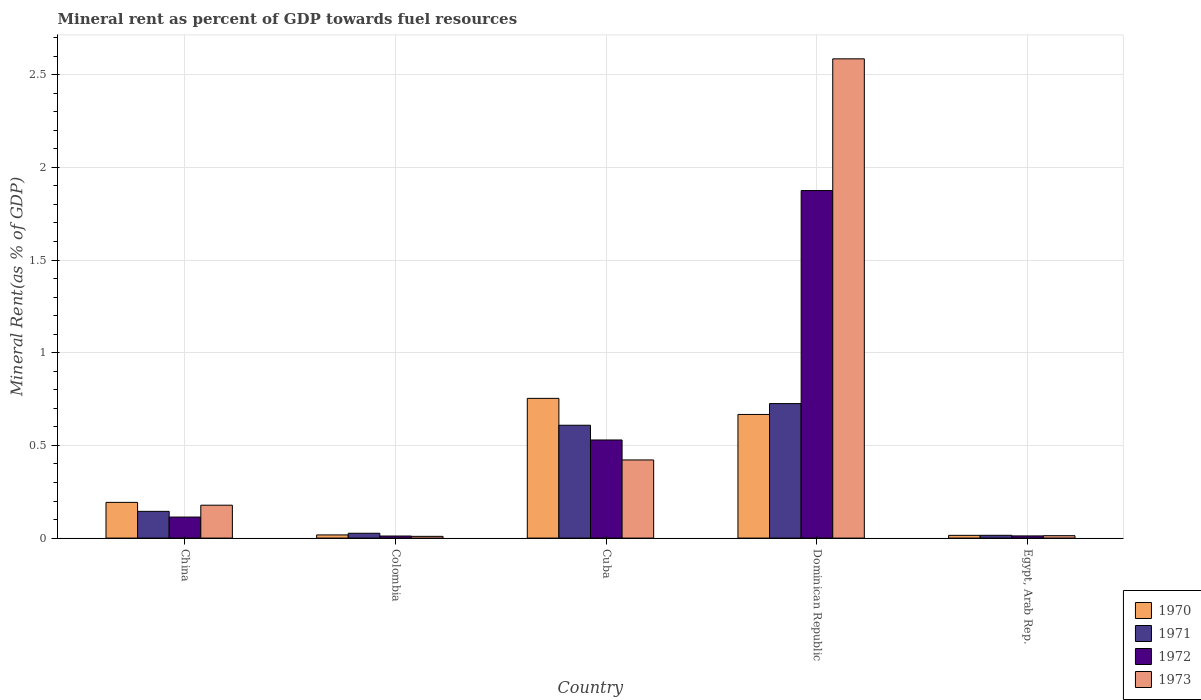How many groups of bars are there?
Ensure brevity in your answer.  5. Are the number of bars per tick equal to the number of legend labels?
Make the answer very short. Yes. Are the number of bars on each tick of the X-axis equal?
Offer a very short reply. Yes. How many bars are there on the 3rd tick from the left?
Make the answer very short. 4. What is the label of the 3rd group of bars from the left?
Your answer should be very brief. Cuba. What is the mineral rent in 1971 in Egypt, Arab Rep.?
Give a very brief answer. 0.02. Across all countries, what is the maximum mineral rent in 1970?
Provide a succinct answer. 0.75. Across all countries, what is the minimum mineral rent in 1970?
Provide a succinct answer. 0.01. In which country was the mineral rent in 1973 maximum?
Give a very brief answer. Dominican Republic. In which country was the mineral rent in 1970 minimum?
Make the answer very short. Egypt, Arab Rep. What is the total mineral rent in 1973 in the graph?
Offer a terse response. 3.21. What is the difference between the mineral rent in 1973 in Colombia and that in Cuba?
Your answer should be very brief. -0.41. What is the difference between the mineral rent in 1971 in China and the mineral rent in 1973 in Cuba?
Ensure brevity in your answer.  -0.28. What is the average mineral rent in 1970 per country?
Ensure brevity in your answer.  0.33. What is the difference between the mineral rent of/in 1970 and mineral rent of/in 1972 in Dominican Republic?
Make the answer very short. -1.21. What is the ratio of the mineral rent in 1970 in Colombia to that in Cuba?
Make the answer very short. 0.02. Is the mineral rent in 1971 in China less than that in Egypt, Arab Rep.?
Give a very brief answer. No. Is the difference between the mineral rent in 1970 in Colombia and Egypt, Arab Rep. greater than the difference between the mineral rent in 1972 in Colombia and Egypt, Arab Rep.?
Keep it short and to the point. Yes. What is the difference between the highest and the second highest mineral rent in 1970?
Your answer should be compact. 0.09. What is the difference between the highest and the lowest mineral rent in 1973?
Your answer should be very brief. 2.58. Is it the case that in every country, the sum of the mineral rent in 1972 and mineral rent in 1973 is greater than the sum of mineral rent in 1970 and mineral rent in 1971?
Keep it short and to the point. No. What does the 1st bar from the left in Dominican Republic represents?
Your answer should be very brief. 1970. Is it the case that in every country, the sum of the mineral rent in 1973 and mineral rent in 1970 is greater than the mineral rent in 1971?
Offer a very short reply. Yes. How many bars are there?
Keep it short and to the point. 20. How many countries are there in the graph?
Make the answer very short. 5. Are the values on the major ticks of Y-axis written in scientific E-notation?
Keep it short and to the point. No. What is the title of the graph?
Your answer should be very brief. Mineral rent as percent of GDP towards fuel resources. Does "1983" appear as one of the legend labels in the graph?
Provide a succinct answer. No. What is the label or title of the X-axis?
Give a very brief answer. Country. What is the label or title of the Y-axis?
Offer a terse response. Mineral Rent(as % of GDP). What is the Mineral Rent(as % of GDP) of 1970 in China?
Provide a succinct answer. 0.19. What is the Mineral Rent(as % of GDP) in 1971 in China?
Keep it short and to the point. 0.14. What is the Mineral Rent(as % of GDP) in 1972 in China?
Your answer should be compact. 0.11. What is the Mineral Rent(as % of GDP) of 1973 in China?
Your answer should be very brief. 0.18. What is the Mineral Rent(as % of GDP) in 1970 in Colombia?
Your answer should be compact. 0.02. What is the Mineral Rent(as % of GDP) in 1971 in Colombia?
Your answer should be compact. 0.03. What is the Mineral Rent(as % of GDP) of 1972 in Colombia?
Your response must be concise. 0.01. What is the Mineral Rent(as % of GDP) of 1973 in Colombia?
Offer a terse response. 0.01. What is the Mineral Rent(as % of GDP) of 1970 in Cuba?
Make the answer very short. 0.75. What is the Mineral Rent(as % of GDP) of 1971 in Cuba?
Your response must be concise. 0.61. What is the Mineral Rent(as % of GDP) in 1972 in Cuba?
Provide a short and direct response. 0.53. What is the Mineral Rent(as % of GDP) of 1973 in Cuba?
Give a very brief answer. 0.42. What is the Mineral Rent(as % of GDP) of 1970 in Dominican Republic?
Give a very brief answer. 0.67. What is the Mineral Rent(as % of GDP) in 1971 in Dominican Republic?
Your answer should be compact. 0.73. What is the Mineral Rent(as % of GDP) in 1972 in Dominican Republic?
Your response must be concise. 1.87. What is the Mineral Rent(as % of GDP) of 1973 in Dominican Republic?
Your response must be concise. 2.59. What is the Mineral Rent(as % of GDP) in 1970 in Egypt, Arab Rep.?
Your answer should be compact. 0.01. What is the Mineral Rent(as % of GDP) in 1971 in Egypt, Arab Rep.?
Make the answer very short. 0.02. What is the Mineral Rent(as % of GDP) of 1972 in Egypt, Arab Rep.?
Make the answer very short. 0.01. What is the Mineral Rent(as % of GDP) of 1973 in Egypt, Arab Rep.?
Offer a very short reply. 0.01. Across all countries, what is the maximum Mineral Rent(as % of GDP) of 1970?
Ensure brevity in your answer.  0.75. Across all countries, what is the maximum Mineral Rent(as % of GDP) in 1971?
Your response must be concise. 0.73. Across all countries, what is the maximum Mineral Rent(as % of GDP) of 1972?
Your response must be concise. 1.87. Across all countries, what is the maximum Mineral Rent(as % of GDP) of 1973?
Ensure brevity in your answer.  2.59. Across all countries, what is the minimum Mineral Rent(as % of GDP) of 1970?
Offer a very short reply. 0.01. Across all countries, what is the minimum Mineral Rent(as % of GDP) of 1971?
Your answer should be compact. 0.02. Across all countries, what is the minimum Mineral Rent(as % of GDP) of 1972?
Provide a short and direct response. 0.01. Across all countries, what is the minimum Mineral Rent(as % of GDP) of 1973?
Keep it short and to the point. 0.01. What is the total Mineral Rent(as % of GDP) of 1970 in the graph?
Offer a very short reply. 1.65. What is the total Mineral Rent(as % of GDP) in 1971 in the graph?
Keep it short and to the point. 1.52. What is the total Mineral Rent(as % of GDP) of 1972 in the graph?
Give a very brief answer. 2.54. What is the total Mineral Rent(as % of GDP) of 1973 in the graph?
Keep it short and to the point. 3.21. What is the difference between the Mineral Rent(as % of GDP) in 1970 in China and that in Colombia?
Provide a short and direct response. 0.18. What is the difference between the Mineral Rent(as % of GDP) in 1971 in China and that in Colombia?
Give a very brief answer. 0.12. What is the difference between the Mineral Rent(as % of GDP) in 1972 in China and that in Colombia?
Offer a terse response. 0.1. What is the difference between the Mineral Rent(as % of GDP) of 1973 in China and that in Colombia?
Make the answer very short. 0.17. What is the difference between the Mineral Rent(as % of GDP) of 1970 in China and that in Cuba?
Ensure brevity in your answer.  -0.56. What is the difference between the Mineral Rent(as % of GDP) in 1971 in China and that in Cuba?
Ensure brevity in your answer.  -0.46. What is the difference between the Mineral Rent(as % of GDP) in 1972 in China and that in Cuba?
Provide a succinct answer. -0.42. What is the difference between the Mineral Rent(as % of GDP) in 1973 in China and that in Cuba?
Offer a very short reply. -0.24. What is the difference between the Mineral Rent(as % of GDP) of 1970 in China and that in Dominican Republic?
Offer a very short reply. -0.47. What is the difference between the Mineral Rent(as % of GDP) in 1971 in China and that in Dominican Republic?
Your answer should be very brief. -0.58. What is the difference between the Mineral Rent(as % of GDP) of 1972 in China and that in Dominican Republic?
Provide a short and direct response. -1.76. What is the difference between the Mineral Rent(as % of GDP) in 1973 in China and that in Dominican Republic?
Keep it short and to the point. -2.41. What is the difference between the Mineral Rent(as % of GDP) in 1970 in China and that in Egypt, Arab Rep.?
Your answer should be very brief. 0.18. What is the difference between the Mineral Rent(as % of GDP) of 1971 in China and that in Egypt, Arab Rep.?
Offer a very short reply. 0.13. What is the difference between the Mineral Rent(as % of GDP) in 1972 in China and that in Egypt, Arab Rep.?
Keep it short and to the point. 0.1. What is the difference between the Mineral Rent(as % of GDP) of 1973 in China and that in Egypt, Arab Rep.?
Offer a terse response. 0.16. What is the difference between the Mineral Rent(as % of GDP) in 1970 in Colombia and that in Cuba?
Keep it short and to the point. -0.74. What is the difference between the Mineral Rent(as % of GDP) of 1971 in Colombia and that in Cuba?
Provide a short and direct response. -0.58. What is the difference between the Mineral Rent(as % of GDP) of 1972 in Colombia and that in Cuba?
Provide a succinct answer. -0.52. What is the difference between the Mineral Rent(as % of GDP) in 1973 in Colombia and that in Cuba?
Offer a very short reply. -0.41. What is the difference between the Mineral Rent(as % of GDP) of 1970 in Colombia and that in Dominican Republic?
Offer a terse response. -0.65. What is the difference between the Mineral Rent(as % of GDP) of 1971 in Colombia and that in Dominican Republic?
Give a very brief answer. -0.7. What is the difference between the Mineral Rent(as % of GDP) of 1972 in Colombia and that in Dominican Republic?
Ensure brevity in your answer.  -1.86. What is the difference between the Mineral Rent(as % of GDP) of 1973 in Colombia and that in Dominican Republic?
Make the answer very short. -2.58. What is the difference between the Mineral Rent(as % of GDP) of 1970 in Colombia and that in Egypt, Arab Rep.?
Keep it short and to the point. 0. What is the difference between the Mineral Rent(as % of GDP) in 1971 in Colombia and that in Egypt, Arab Rep.?
Offer a terse response. 0.01. What is the difference between the Mineral Rent(as % of GDP) in 1972 in Colombia and that in Egypt, Arab Rep.?
Offer a terse response. -0. What is the difference between the Mineral Rent(as % of GDP) in 1973 in Colombia and that in Egypt, Arab Rep.?
Provide a succinct answer. -0. What is the difference between the Mineral Rent(as % of GDP) in 1970 in Cuba and that in Dominican Republic?
Provide a succinct answer. 0.09. What is the difference between the Mineral Rent(as % of GDP) of 1971 in Cuba and that in Dominican Republic?
Provide a short and direct response. -0.12. What is the difference between the Mineral Rent(as % of GDP) of 1972 in Cuba and that in Dominican Republic?
Offer a terse response. -1.35. What is the difference between the Mineral Rent(as % of GDP) of 1973 in Cuba and that in Dominican Republic?
Ensure brevity in your answer.  -2.16. What is the difference between the Mineral Rent(as % of GDP) of 1970 in Cuba and that in Egypt, Arab Rep.?
Provide a short and direct response. 0.74. What is the difference between the Mineral Rent(as % of GDP) of 1971 in Cuba and that in Egypt, Arab Rep.?
Offer a terse response. 0.59. What is the difference between the Mineral Rent(as % of GDP) in 1972 in Cuba and that in Egypt, Arab Rep.?
Offer a very short reply. 0.52. What is the difference between the Mineral Rent(as % of GDP) of 1973 in Cuba and that in Egypt, Arab Rep.?
Your answer should be compact. 0.41. What is the difference between the Mineral Rent(as % of GDP) of 1970 in Dominican Republic and that in Egypt, Arab Rep.?
Provide a short and direct response. 0.65. What is the difference between the Mineral Rent(as % of GDP) of 1971 in Dominican Republic and that in Egypt, Arab Rep.?
Provide a succinct answer. 0.71. What is the difference between the Mineral Rent(as % of GDP) in 1972 in Dominican Republic and that in Egypt, Arab Rep.?
Make the answer very short. 1.86. What is the difference between the Mineral Rent(as % of GDP) in 1973 in Dominican Republic and that in Egypt, Arab Rep.?
Your response must be concise. 2.57. What is the difference between the Mineral Rent(as % of GDP) of 1970 in China and the Mineral Rent(as % of GDP) of 1971 in Colombia?
Offer a terse response. 0.17. What is the difference between the Mineral Rent(as % of GDP) in 1970 in China and the Mineral Rent(as % of GDP) in 1972 in Colombia?
Provide a succinct answer. 0.18. What is the difference between the Mineral Rent(as % of GDP) of 1970 in China and the Mineral Rent(as % of GDP) of 1973 in Colombia?
Ensure brevity in your answer.  0.18. What is the difference between the Mineral Rent(as % of GDP) in 1971 in China and the Mineral Rent(as % of GDP) in 1972 in Colombia?
Provide a short and direct response. 0.13. What is the difference between the Mineral Rent(as % of GDP) of 1971 in China and the Mineral Rent(as % of GDP) of 1973 in Colombia?
Give a very brief answer. 0.13. What is the difference between the Mineral Rent(as % of GDP) in 1972 in China and the Mineral Rent(as % of GDP) in 1973 in Colombia?
Your answer should be compact. 0.1. What is the difference between the Mineral Rent(as % of GDP) of 1970 in China and the Mineral Rent(as % of GDP) of 1971 in Cuba?
Your answer should be compact. -0.42. What is the difference between the Mineral Rent(as % of GDP) in 1970 in China and the Mineral Rent(as % of GDP) in 1972 in Cuba?
Your answer should be compact. -0.34. What is the difference between the Mineral Rent(as % of GDP) in 1970 in China and the Mineral Rent(as % of GDP) in 1973 in Cuba?
Provide a succinct answer. -0.23. What is the difference between the Mineral Rent(as % of GDP) in 1971 in China and the Mineral Rent(as % of GDP) in 1972 in Cuba?
Keep it short and to the point. -0.39. What is the difference between the Mineral Rent(as % of GDP) in 1971 in China and the Mineral Rent(as % of GDP) in 1973 in Cuba?
Offer a terse response. -0.28. What is the difference between the Mineral Rent(as % of GDP) of 1972 in China and the Mineral Rent(as % of GDP) of 1973 in Cuba?
Your answer should be very brief. -0.31. What is the difference between the Mineral Rent(as % of GDP) in 1970 in China and the Mineral Rent(as % of GDP) in 1971 in Dominican Republic?
Ensure brevity in your answer.  -0.53. What is the difference between the Mineral Rent(as % of GDP) in 1970 in China and the Mineral Rent(as % of GDP) in 1972 in Dominican Republic?
Give a very brief answer. -1.68. What is the difference between the Mineral Rent(as % of GDP) of 1970 in China and the Mineral Rent(as % of GDP) of 1973 in Dominican Republic?
Your response must be concise. -2.39. What is the difference between the Mineral Rent(as % of GDP) of 1971 in China and the Mineral Rent(as % of GDP) of 1972 in Dominican Republic?
Provide a succinct answer. -1.73. What is the difference between the Mineral Rent(as % of GDP) in 1971 in China and the Mineral Rent(as % of GDP) in 1973 in Dominican Republic?
Ensure brevity in your answer.  -2.44. What is the difference between the Mineral Rent(as % of GDP) of 1972 in China and the Mineral Rent(as % of GDP) of 1973 in Dominican Republic?
Your answer should be very brief. -2.47. What is the difference between the Mineral Rent(as % of GDP) in 1970 in China and the Mineral Rent(as % of GDP) in 1971 in Egypt, Arab Rep.?
Keep it short and to the point. 0.18. What is the difference between the Mineral Rent(as % of GDP) of 1970 in China and the Mineral Rent(as % of GDP) of 1972 in Egypt, Arab Rep.?
Keep it short and to the point. 0.18. What is the difference between the Mineral Rent(as % of GDP) of 1970 in China and the Mineral Rent(as % of GDP) of 1973 in Egypt, Arab Rep.?
Keep it short and to the point. 0.18. What is the difference between the Mineral Rent(as % of GDP) of 1971 in China and the Mineral Rent(as % of GDP) of 1972 in Egypt, Arab Rep.?
Provide a short and direct response. 0.13. What is the difference between the Mineral Rent(as % of GDP) of 1971 in China and the Mineral Rent(as % of GDP) of 1973 in Egypt, Arab Rep.?
Your response must be concise. 0.13. What is the difference between the Mineral Rent(as % of GDP) in 1972 in China and the Mineral Rent(as % of GDP) in 1973 in Egypt, Arab Rep.?
Offer a terse response. 0.1. What is the difference between the Mineral Rent(as % of GDP) in 1970 in Colombia and the Mineral Rent(as % of GDP) in 1971 in Cuba?
Your answer should be compact. -0.59. What is the difference between the Mineral Rent(as % of GDP) in 1970 in Colombia and the Mineral Rent(as % of GDP) in 1972 in Cuba?
Keep it short and to the point. -0.51. What is the difference between the Mineral Rent(as % of GDP) in 1970 in Colombia and the Mineral Rent(as % of GDP) in 1973 in Cuba?
Offer a terse response. -0.4. What is the difference between the Mineral Rent(as % of GDP) in 1971 in Colombia and the Mineral Rent(as % of GDP) in 1972 in Cuba?
Your answer should be very brief. -0.5. What is the difference between the Mineral Rent(as % of GDP) of 1971 in Colombia and the Mineral Rent(as % of GDP) of 1973 in Cuba?
Your answer should be very brief. -0.4. What is the difference between the Mineral Rent(as % of GDP) in 1972 in Colombia and the Mineral Rent(as % of GDP) in 1973 in Cuba?
Offer a terse response. -0.41. What is the difference between the Mineral Rent(as % of GDP) in 1970 in Colombia and the Mineral Rent(as % of GDP) in 1971 in Dominican Republic?
Provide a short and direct response. -0.71. What is the difference between the Mineral Rent(as % of GDP) in 1970 in Colombia and the Mineral Rent(as % of GDP) in 1972 in Dominican Republic?
Your response must be concise. -1.86. What is the difference between the Mineral Rent(as % of GDP) in 1970 in Colombia and the Mineral Rent(as % of GDP) in 1973 in Dominican Republic?
Provide a succinct answer. -2.57. What is the difference between the Mineral Rent(as % of GDP) of 1971 in Colombia and the Mineral Rent(as % of GDP) of 1972 in Dominican Republic?
Provide a succinct answer. -1.85. What is the difference between the Mineral Rent(as % of GDP) in 1971 in Colombia and the Mineral Rent(as % of GDP) in 1973 in Dominican Republic?
Ensure brevity in your answer.  -2.56. What is the difference between the Mineral Rent(as % of GDP) in 1972 in Colombia and the Mineral Rent(as % of GDP) in 1973 in Dominican Republic?
Your answer should be compact. -2.57. What is the difference between the Mineral Rent(as % of GDP) in 1970 in Colombia and the Mineral Rent(as % of GDP) in 1971 in Egypt, Arab Rep.?
Give a very brief answer. 0. What is the difference between the Mineral Rent(as % of GDP) of 1970 in Colombia and the Mineral Rent(as % of GDP) of 1972 in Egypt, Arab Rep.?
Ensure brevity in your answer.  0.01. What is the difference between the Mineral Rent(as % of GDP) in 1970 in Colombia and the Mineral Rent(as % of GDP) in 1973 in Egypt, Arab Rep.?
Your answer should be very brief. 0. What is the difference between the Mineral Rent(as % of GDP) in 1971 in Colombia and the Mineral Rent(as % of GDP) in 1972 in Egypt, Arab Rep.?
Keep it short and to the point. 0.01. What is the difference between the Mineral Rent(as % of GDP) of 1971 in Colombia and the Mineral Rent(as % of GDP) of 1973 in Egypt, Arab Rep.?
Provide a succinct answer. 0.01. What is the difference between the Mineral Rent(as % of GDP) of 1972 in Colombia and the Mineral Rent(as % of GDP) of 1973 in Egypt, Arab Rep.?
Your response must be concise. -0. What is the difference between the Mineral Rent(as % of GDP) of 1970 in Cuba and the Mineral Rent(as % of GDP) of 1971 in Dominican Republic?
Keep it short and to the point. 0.03. What is the difference between the Mineral Rent(as % of GDP) of 1970 in Cuba and the Mineral Rent(as % of GDP) of 1972 in Dominican Republic?
Your answer should be very brief. -1.12. What is the difference between the Mineral Rent(as % of GDP) of 1970 in Cuba and the Mineral Rent(as % of GDP) of 1973 in Dominican Republic?
Offer a very short reply. -1.83. What is the difference between the Mineral Rent(as % of GDP) in 1971 in Cuba and the Mineral Rent(as % of GDP) in 1972 in Dominican Republic?
Keep it short and to the point. -1.27. What is the difference between the Mineral Rent(as % of GDP) of 1971 in Cuba and the Mineral Rent(as % of GDP) of 1973 in Dominican Republic?
Give a very brief answer. -1.98. What is the difference between the Mineral Rent(as % of GDP) of 1972 in Cuba and the Mineral Rent(as % of GDP) of 1973 in Dominican Republic?
Make the answer very short. -2.06. What is the difference between the Mineral Rent(as % of GDP) in 1970 in Cuba and the Mineral Rent(as % of GDP) in 1971 in Egypt, Arab Rep.?
Your answer should be compact. 0.74. What is the difference between the Mineral Rent(as % of GDP) of 1970 in Cuba and the Mineral Rent(as % of GDP) of 1972 in Egypt, Arab Rep.?
Offer a terse response. 0.74. What is the difference between the Mineral Rent(as % of GDP) of 1970 in Cuba and the Mineral Rent(as % of GDP) of 1973 in Egypt, Arab Rep.?
Give a very brief answer. 0.74. What is the difference between the Mineral Rent(as % of GDP) in 1971 in Cuba and the Mineral Rent(as % of GDP) in 1972 in Egypt, Arab Rep.?
Offer a terse response. 0.6. What is the difference between the Mineral Rent(as % of GDP) of 1971 in Cuba and the Mineral Rent(as % of GDP) of 1973 in Egypt, Arab Rep.?
Make the answer very short. 0.6. What is the difference between the Mineral Rent(as % of GDP) of 1972 in Cuba and the Mineral Rent(as % of GDP) of 1973 in Egypt, Arab Rep.?
Keep it short and to the point. 0.52. What is the difference between the Mineral Rent(as % of GDP) in 1970 in Dominican Republic and the Mineral Rent(as % of GDP) in 1971 in Egypt, Arab Rep.?
Offer a terse response. 0.65. What is the difference between the Mineral Rent(as % of GDP) of 1970 in Dominican Republic and the Mineral Rent(as % of GDP) of 1972 in Egypt, Arab Rep.?
Offer a very short reply. 0.66. What is the difference between the Mineral Rent(as % of GDP) in 1970 in Dominican Republic and the Mineral Rent(as % of GDP) in 1973 in Egypt, Arab Rep.?
Make the answer very short. 0.65. What is the difference between the Mineral Rent(as % of GDP) in 1971 in Dominican Republic and the Mineral Rent(as % of GDP) in 1972 in Egypt, Arab Rep.?
Your answer should be compact. 0.71. What is the difference between the Mineral Rent(as % of GDP) in 1971 in Dominican Republic and the Mineral Rent(as % of GDP) in 1973 in Egypt, Arab Rep.?
Offer a very short reply. 0.71. What is the difference between the Mineral Rent(as % of GDP) of 1972 in Dominican Republic and the Mineral Rent(as % of GDP) of 1973 in Egypt, Arab Rep.?
Your answer should be compact. 1.86. What is the average Mineral Rent(as % of GDP) in 1970 per country?
Give a very brief answer. 0.33. What is the average Mineral Rent(as % of GDP) in 1971 per country?
Ensure brevity in your answer.  0.3. What is the average Mineral Rent(as % of GDP) of 1972 per country?
Your response must be concise. 0.51. What is the average Mineral Rent(as % of GDP) of 1973 per country?
Your answer should be compact. 0.64. What is the difference between the Mineral Rent(as % of GDP) in 1970 and Mineral Rent(as % of GDP) in 1971 in China?
Provide a short and direct response. 0.05. What is the difference between the Mineral Rent(as % of GDP) of 1970 and Mineral Rent(as % of GDP) of 1972 in China?
Ensure brevity in your answer.  0.08. What is the difference between the Mineral Rent(as % of GDP) in 1970 and Mineral Rent(as % of GDP) in 1973 in China?
Ensure brevity in your answer.  0.02. What is the difference between the Mineral Rent(as % of GDP) of 1971 and Mineral Rent(as % of GDP) of 1972 in China?
Your response must be concise. 0.03. What is the difference between the Mineral Rent(as % of GDP) in 1971 and Mineral Rent(as % of GDP) in 1973 in China?
Your answer should be compact. -0.03. What is the difference between the Mineral Rent(as % of GDP) in 1972 and Mineral Rent(as % of GDP) in 1973 in China?
Make the answer very short. -0.06. What is the difference between the Mineral Rent(as % of GDP) of 1970 and Mineral Rent(as % of GDP) of 1971 in Colombia?
Make the answer very short. -0.01. What is the difference between the Mineral Rent(as % of GDP) in 1970 and Mineral Rent(as % of GDP) in 1972 in Colombia?
Make the answer very short. 0.01. What is the difference between the Mineral Rent(as % of GDP) of 1970 and Mineral Rent(as % of GDP) of 1973 in Colombia?
Keep it short and to the point. 0.01. What is the difference between the Mineral Rent(as % of GDP) of 1971 and Mineral Rent(as % of GDP) of 1972 in Colombia?
Keep it short and to the point. 0.01. What is the difference between the Mineral Rent(as % of GDP) of 1971 and Mineral Rent(as % of GDP) of 1973 in Colombia?
Give a very brief answer. 0.02. What is the difference between the Mineral Rent(as % of GDP) in 1972 and Mineral Rent(as % of GDP) in 1973 in Colombia?
Offer a very short reply. 0. What is the difference between the Mineral Rent(as % of GDP) in 1970 and Mineral Rent(as % of GDP) in 1971 in Cuba?
Provide a succinct answer. 0.14. What is the difference between the Mineral Rent(as % of GDP) in 1970 and Mineral Rent(as % of GDP) in 1972 in Cuba?
Ensure brevity in your answer.  0.22. What is the difference between the Mineral Rent(as % of GDP) of 1970 and Mineral Rent(as % of GDP) of 1973 in Cuba?
Your answer should be compact. 0.33. What is the difference between the Mineral Rent(as % of GDP) of 1971 and Mineral Rent(as % of GDP) of 1972 in Cuba?
Your answer should be compact. 0.08. What is the difference between the Mineral Rent(as % of GDP) of 1971 and Mineral Rent(as % of GDP) of 1973 in Cuba?
Keep it short and to the point. 0.19. What is the difference between the Mineral Rent(as % of GDP) of 1972 and Mineral Rent(as % of GDP) of 1973 in Cuba?
Your answer should be very brief. 0.11. What is the difference between the Mineral Rent(as % of GDP) in 1970 and Mineral Rent(as % of GDP) in 1971 in Dominican Republic?
Your response must be concise. -0.06. What is the difference between the Mineral Rent(as % of GDP) in 1970 and Mineral Rent(as % of GDP) in 1972 in Dominican Republic?
Ensure brevity in your answer.  -1.21. What is the difference between the Mineral Rent(as % of GDP) of 1970 and Mineral Rent(as % of GDP) of 1973 in Dominican Republic?
Provide a succinct answer. -1.92. What is the difference between the Mineral Rent(as % of GDP) in 1971 and Mineral Rent(as % of GDP) in 1972 in Dominican Republic?
Provide a short and direct response. -1.15. What is the difference between the Mineral Rent(as % of GDP) of 1971 and Mineral Rent(as % of GDP) of 1973 in Dominican Republic?
Keep it short and to the point. -1.86. What is the difference between the Mineral Rent(as % of GDP) in 1972 and Mineral Rent(as % of GDP) in 1973 in Dominican Republic?
Give a very brief answer. -0.71. What is the difference between the Mineral Rent(as % of GDP) in 1970 and Mineral Rent(as % of GDP) in 1971 in Egypt, Arab Rep.?
Your answer should be very brief. -0. What is the difference between the Mineral Rent(as % of GDP) in 1970 and Mineral Rent(as % of GDP) in 1972 in Egypt, Arab Rep.?
Your answer should be compact. 0. What is the difference between the Mineral Rent(as % of GDP) of 1970 and Mineral Rent(as % of GDP) of 1973 in Egypt, Arab Rep.?
Keep it short and to the point. 0. What is the difference between the Mineral Rent(as % of GDP) of 1971 and Mineral Rent(as % of GDP) of 1972 in Egypt, Arab Rep.?
Keep it short and to the point. 0. What is the difference between the Mineral Rent(as % of GDP) of 1971 and Mineral Rent(as % of GDP) of 1973 in Egypt, Arab Rep.?
Offer a terse response. 0. What is the difference between the Mineral Rent(as % of GDP) in 1972 and Mineral Rent(as % of GDP) in 1973 in Egypt, Arab Rep.?
Provide a succinct answer. -0. What is the ratio of the Mineral Rent(as % of GDP) of 1970 in China to that in Colombia?
Keep it short and to the point. 11.21. What is the ratio of the Mineral Rent(as % of GDP) of 1971 in China to that in Colombia?
Provide a succinct answer. 5.53. What is the ratio of the Mineral Rent(as % of GDP) in 1972 in China to that in Colombia?
Make the answer very short. 10.17. What is the ratio of the Mineral Rent(as % of GDP) of 1973 in China to that in Colombia?
Your answer should be compact. 18.98. What is the ratio of the Mineral Rent(as % of GDP) of 1970 in China to that in Cuba?
Offer a terse response. 0.26. What is the ratio of the Mineral Rent(as % of GDP) of 1971 in China to that in Cuba?
Offer a very short reply. 0.24. What is the ratio of the Mineral Rent(as % of GDP) in 1972 in China to that in Cuba?
Give a very brief answer. 0.21. What is the ratio of the Mineral Rent(as % of GDP) of 1973 in China to that in Cuba?
Give a very brief answer. 0.42. What is the ratio of the Mineral Rent(as % of GDP) of 1970 in China to that in Dominican Republic?
Make the answer very short. 0.29. What is the ratio of the Mineral Rent(as % of GDP) of 1971 in China to that in Dominican Republic?
Make the answer very short. 0.2. What is the ratio of the Mineral Rent(as % of GDP) in 1972 in China to that in Dominican Republic?
Your response must be concise. 0.06. What is the ratio of the Mineral Rent(as % of GDP) in 1973 in China to that in Dominican Republic?
Your response must be concise. 0.07. What is the ratio of the Mineral Rent(as % of GDP) in 1970 in China to that in Egypt, Arab Rep.?
Provide a short and direct response. 13.03. What is the ratio of the Mineral Rent(as % of GDP) of 1971 in China to that in Egypt, Arab Rep.?
Keep it short and to the point. 9.6. What is the ratio of the Mineral Rent(as % of GDP) of 1972 in China to that in Egypt, Arab Rep.?
Provide a succinct answer. 9.67. What is the ratio of the Mineral Rent(as % of GDP) in 1973 in China to that in Egypt, Arab Rep.?
Your response must be concise. 13.6. What is the ratio of the Mineral Rent(as % of GDP) in 1970 in Colombia to that in Cuba?
Offer a very short reply. 0.02. What is the ratio of the Mineral Rent(as % of GDP) in 1971 in Colombia to that in Cuba?
Ensure brevity in your answer.  0.04. What is the ratio of the Mineral Rent(as % of GDP) of 1972 in Colombia to that in Cuba?
Offer a terse response. 0.02. What is the ratio of the Mineral Rent(as % of GDP) in 1973 in Colombia to that in Cuba?
Your answer should be compact. 0.02. What is the ratio of the Mineral Rent(as % of GDP) in 1970 in Colombia to that in Dominican Republic?
Make the answer very short. 0.03. What is the ratio of the Mineral Rent(as % of GDP) of 1971 in Colombia to that in Dominican Republic?
Offer a very short reply. 0.04. What is the ratio of the Mineral Rent(as % of GDP) in 1972 in Colombia to that in Dominican Republic?
Ensure brevity in your answer.  0.01. What is the ratio of the Mineral Rent(as % of GDP) in 1973 in Colombia to that in Dominican Republic?
Your response must be concise. 0. What is the ratio of the Mineral Rent(as % of GDP) in 1970 in Colombia to that in Egypt, Arab Rep.?
Give a very brief answer. 1.16. What is the ratio of the Mineral Rent(as % of GDP) of 1971 in Colombia to that in Egypt, Arab Rep.?
Keep it short and to the point. 1.74. What is the ratio of the Mineral Rent(as % of GDP) in 1972 in Colombia to that in Egypt, Arab Rep.?
Give a very brief answer. 0.95. What is the ratio of the Mineral Rent(as % of GDP) of 1973 in Colombia to that in Egypt, Arab Rep.?
Offer a very short reply. 0.72. What is the ratio of the Mineral Rent(as % of GDP) in 1970 in Cuba to that in Dominican Republic?
Your answer should be very brief. 1.13. What is the ratio of the Mineral Rent(as % of GDP) in 1971 in Cuba to that in Dominican Republic?
Provide a succinct answer. 0.84. What is the ratio of the Mineral Rent(as % of GDP) of 1972 in Cuba to that in Dominican Republic?
Keep it short and to the point. 0.28. What is the ratio of the Mineral Rent(as % of GDP) of 1973 in Cuba to that in Dominican Republic?
Your answer should be compact. 0.16. What is the ratio of the Mineral Rent(as % of GDP) of 1970 in Cuba to that in Egypt, Arab Rep.?
Make the answer very short. 51. What is the ratio of the Mineral Rent(as % of GDP) of 1971 in Cuba to that in Egypt, Arab Rep.?
Your answer should be very brief. 40.5. What is the ratio of the Mineral Rent(as % of GDP) in 1972 in Cuba to that in Egypt, Arab Rep.?
Offer a terse response. 45.11. What is the ratio of the Mineral Rent(as % of GDP) in 1973 in Cuba to that in Egypt, Arab Rep.?
Provide a short and direct response. 32.3. What is the ratio of the Mineral Rent(as % of GDP) in 1970 in Dominican Republic to that in Egypt, Arab Rep.?
Offer a terse response. 45.13. What is the ratio of the Mineral Rent(as % of GDP) in 1971 in Dominican Republic to that in Egypt, Arab Rep.?
Offer a terse response. 48.27. What is the ratio of the Mineral Rent(as % of GDP) of 1972 in Dominican Republic to that in Egypt, Arab Rep.?
Provide a succinct answer. 159.8. What is the ratio of the Mineral Rent(as % of GDP) in 1973 in Dominican Republic to that in Egypt, Arab Rep.?
Your answer should be compact. 198.1. What is the difference between the highest and the second highest Mineral Rent(as % of GDP) in 1970?
Give a very brief answer. 0.09. What is the difference between the highest and the second highest Mineral Rent(as % of GDP) in 1971?
Offer a terse response. 0.12. What is the difference between the highest and the second highest Mineral Rent(as % of GDP) in 1972?
Offer a terse response. 1.35. What is the difference between the highest and the second highest Mineral Rent(as % of GDP) of 1973?
Your answer should be compact. 2.16. What is the difference between the highest and the lowest Mineral Rent(as % of GDP) of 1970?
Your response must be concise. 0.74. What is the difference between the highest and the lowest Mineral Rent(as % of GDP) in 1971?
Ensure brevity in your answer.  0.71. What is the difference between the highest and the lowest Mineral Rent(as % of GDP) in 1972?
Keep it short and to the point. 1.86. What is the difference between the highest and the lowest Mineral Rent(as % of GDP) of 1973?
Give a very brief answer. 2.58. 